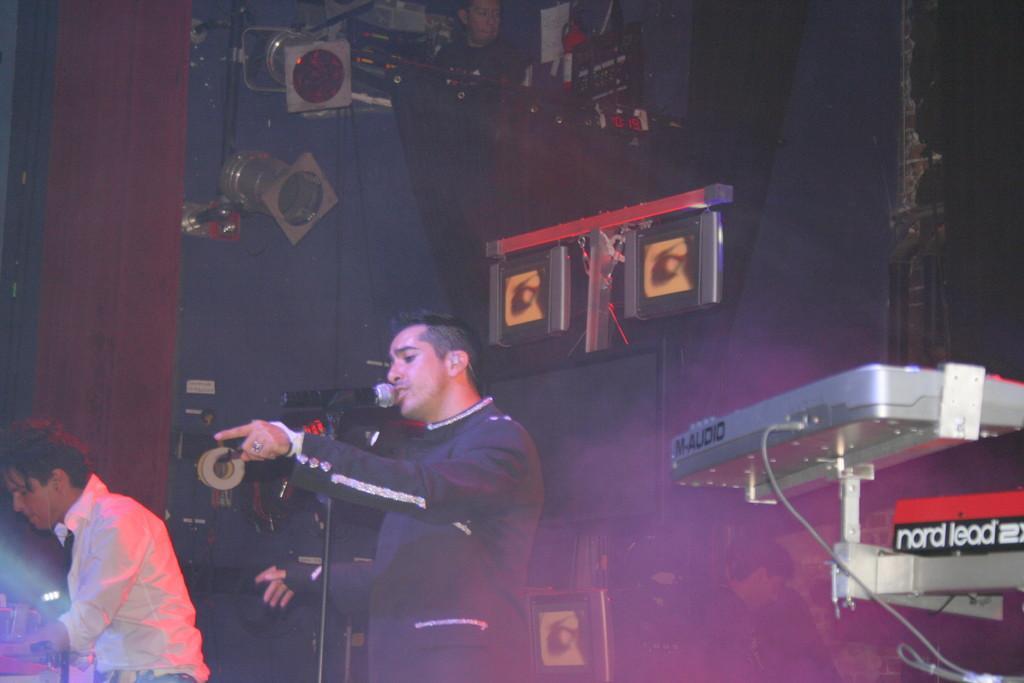Describe this image in one or two sentences. In this image we can see persons, a microphone and some other objects. On the right side of the image there is an object. In the background of the image there is a person, lights and some other objects. 